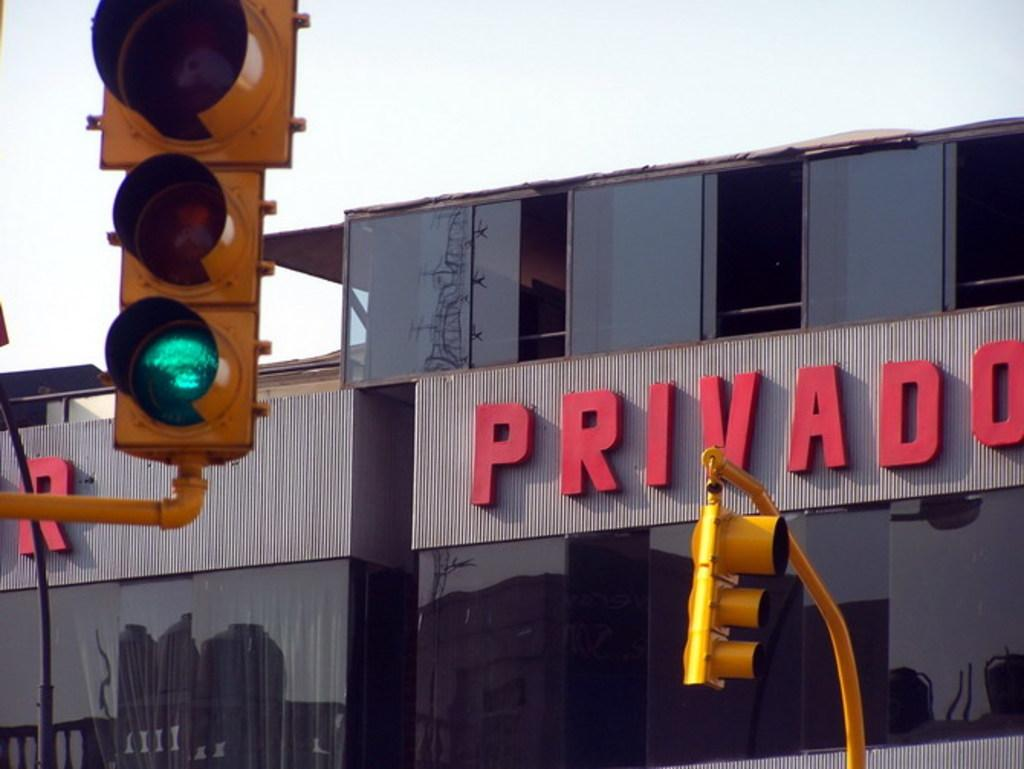<image>
Write a terse but informative summary of the picture. a building that had the word privado on it 